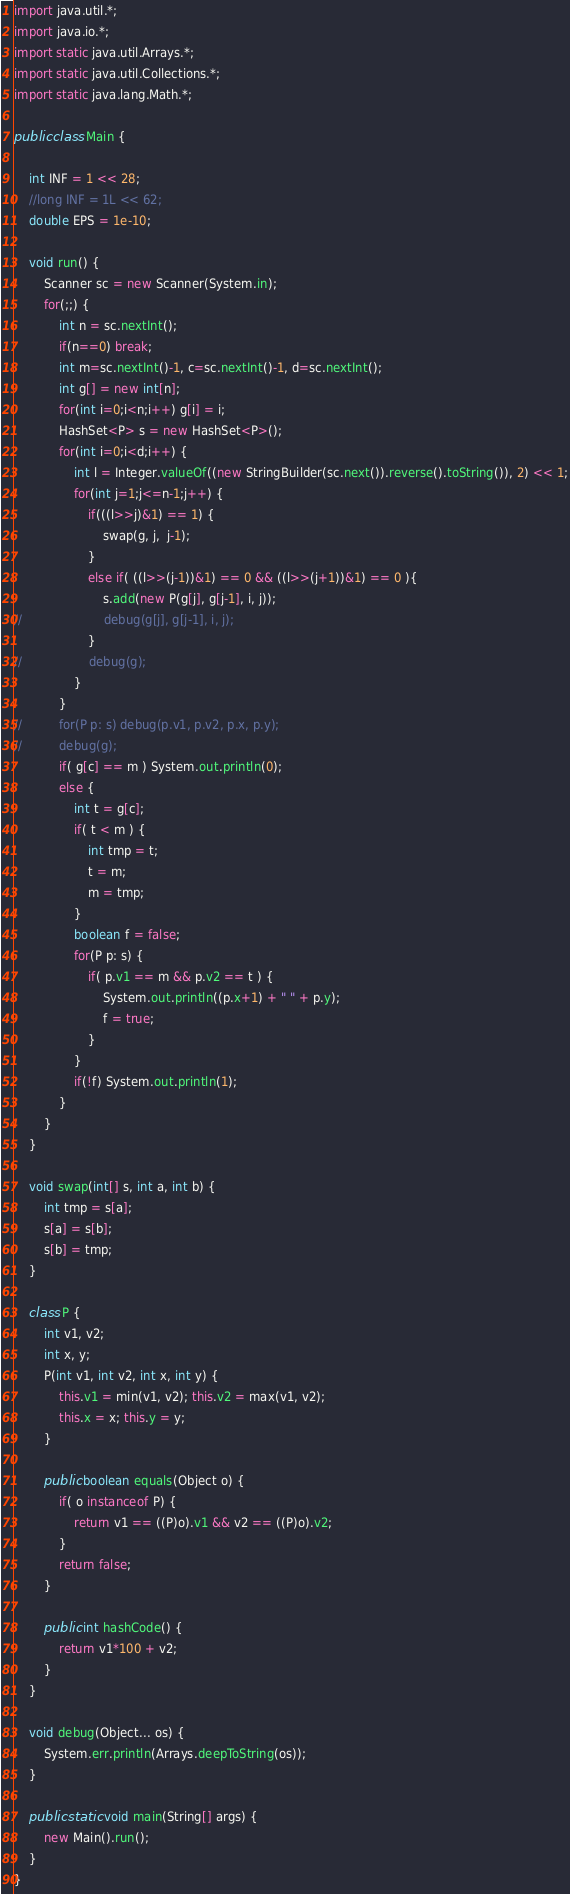Convert code to text. <code><loc_0><loc_0><loc_500><loc_500><_Java_>
import java.util.*;
import java.io.*;
import static java.util.Arrays.*;
import static java.util.Collections.*;
import static java.lang.Math.*;

public class Main {

	int INF = 1 << 28;
	//long INF = 1L << 62;
	double EPS = 1e-10;

	void run() {
		Scanner sc = new Scanner(System.in);
		for(;;) {
			int n = sc.nextInt();
			if(n==0) break;
			int m=sc.nextInt()-1, c=sc.nextInt()-1, d=sc.nextInt();
			int g[] = new int[n];
			for(int i=0;i<n;i++) g[i] = i;
			HashSet<P> s = new HashSet<P>();
			for(int i=0;i<d;i++) {
				int l = Integer.valueOf((new StringBuilder(sc.next()).reverse().toString()), 2) << 1;
				for(int j=1;j<=n-1;j++) {
					if(((l>>j)&1) == 1) {
						swap(g, j,  j-1);
					}
					else if( ((l>>(j-1))&1) == 0 && ((l>>(j+1))&1) == 0 ){
						s.add(new P(g[j], g[j-1], i, j));
//						debug(g[j], g[j-1], i, j);
					}
//					debug(g);
				}
			}
//			for(P p: s) debug(p.v1, p.v2, p.x, p.y);
//			debug(g);
			if( g[c] == m ) System.out.println(0);
			else {
				int t = g[c];
				if( t < m ) {
					int tmp = t; 
					t = m;
					m = tmp;
				}
				boolean f = false;
				for(P p: s) {
					if( p.v1 == m && p.v2 == t ) {
						System.out.println((p.x+1) + " " + p.y);
						f = true;
					}
				}
				if(!f) System.out.println(1);
			}
		}
	}
	
	void swap(int[] s, int a, int b) {
		int tmp = s[a];
		s[a] = s[b];
		s[b] = tmp;
	}
	
	class P {
		int v1, v2;
		int x, y;
		P(int v1, int v2, int x, int y) {
			this.v1 = min(v1, v2); this.v2 = max(v1, v2);
			this.x = x; this.y = y;
		}
		
		public boolean equals(Object o) {
			if( o instanceof P) {
				return v1 == ((P)o).v1 && v2 == ((P)o).v2;
			}
			return false;
		}
		
		public int hashCode() {
			return v1*100 + v2;
		}
	}

	void debug(Object... os) {
		System.err.println(Arrays.deepToString(os));
	}

	public static void main(String[] args) {
		new Main().run();
	}
}</code> 